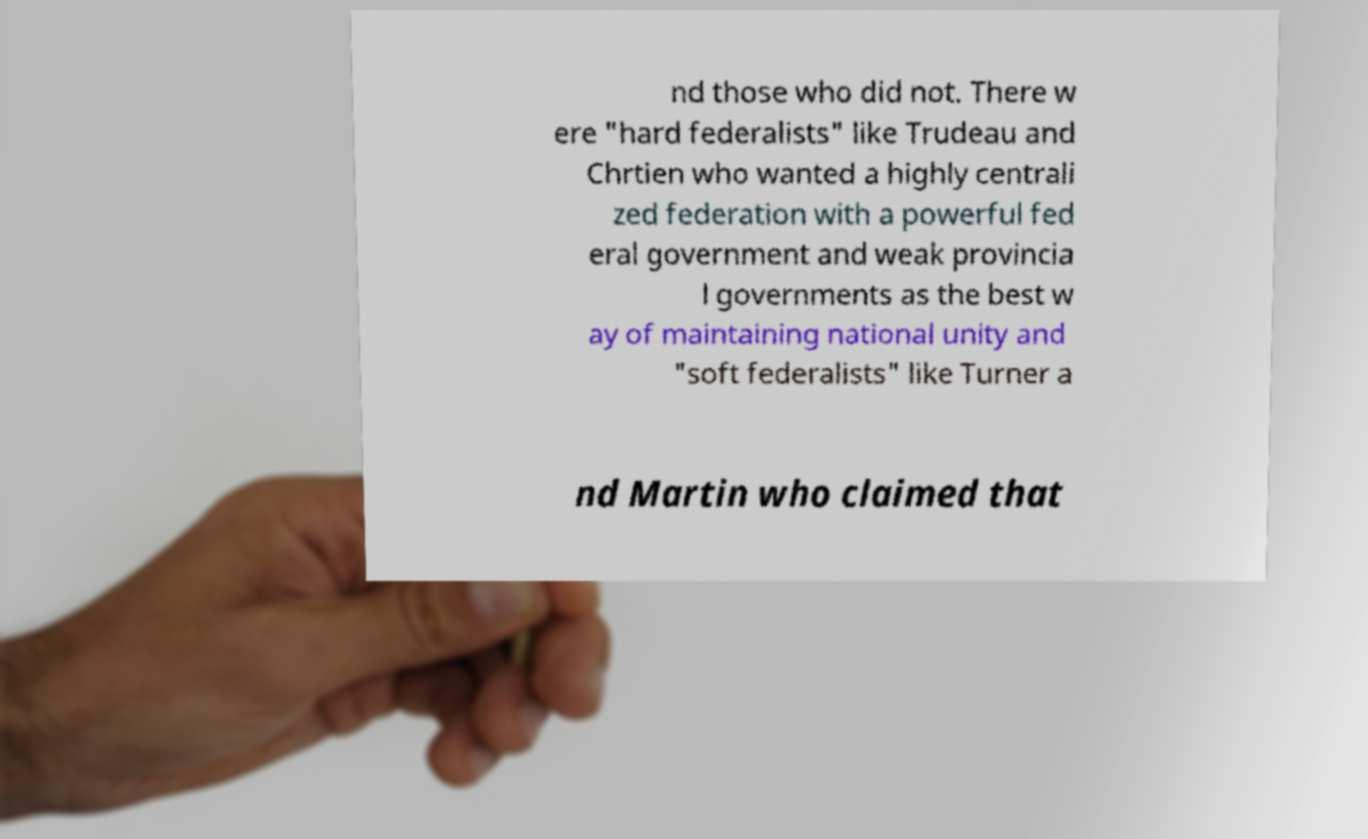Please read and relay the text visible in this image. What does it say? nd those who did not. There w ere "hard federalists" like Trudeau and Chrtien who wanted a highly centrali zed federation with a powerful fed eral government and weak provincia l governments as the best w ay of maintaining national unity and "soft federalists" like Turner a nd Martin who claimed that 